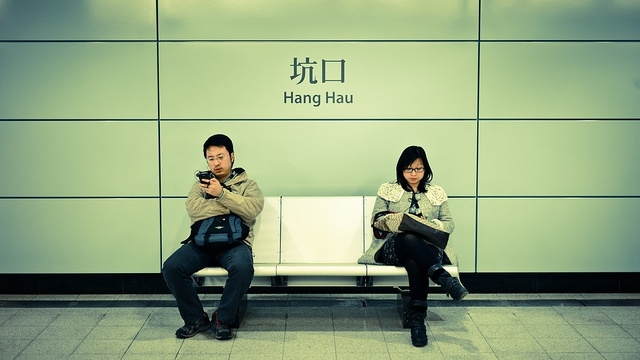Describe the objects in this image and their specific colors. I can see bench in teal, lightyellow, black, and khaki tones, people in teal, black, tan, gray, and blue tones, people in teal, black, khaki, darkgray, and tan tones, backpack in teal, black, blue, and darkblue tones, and handbag in teal, black, tan, khaki, and gray tones in this image. 